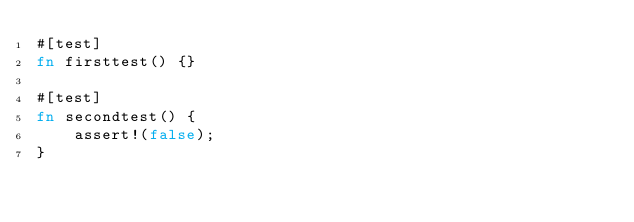<code> <loc_0><loc_0><loc_500><loc_500><_Rust_>#[test]
fn firsttest() {}

#[test]
fn secondtest() {
    assert!(false);
}
</code> 